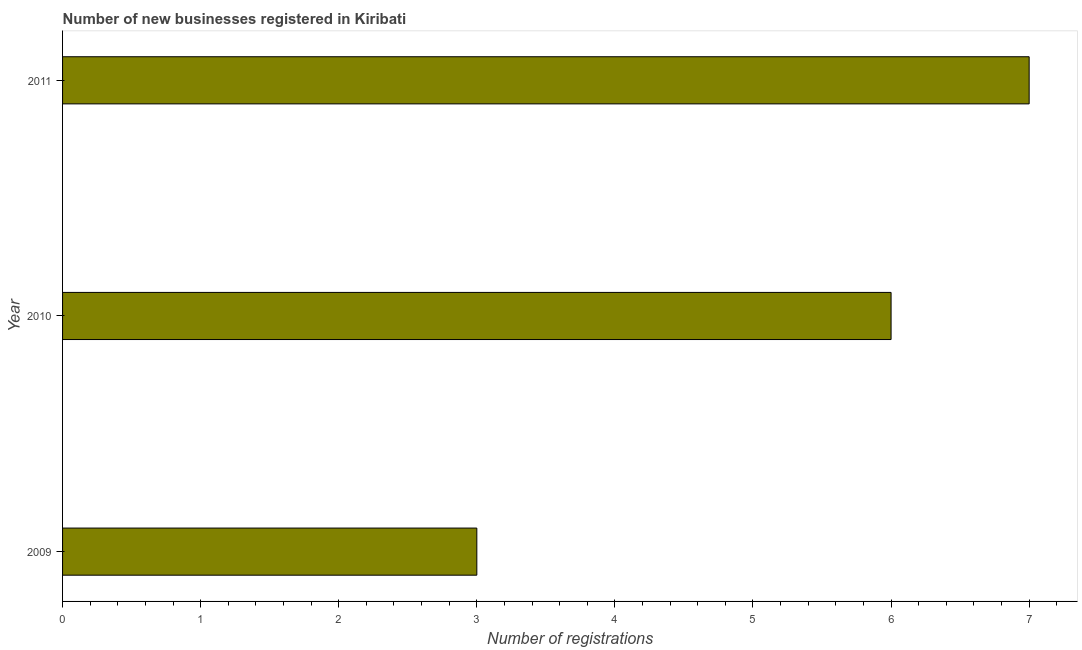Does the graph contain grids?
Provide a short and direct response. No. What is the title of the graph?
Offer a terse response. Number of new businesses registered in Kiribati. What is the label or title of the X-axis?
Offer a terse response. Number of registrations. What is the number of new business registrations in 2011?
Provide a short and direct response. 7. Across all years, what is the maximum number of new business registrations?
Provide a succinct answer. 7. Across all years, what is the minimum number of new business registrations?
Offer a very short reply. 3. What is the sum of the number of new business registrations?
Your response must be concise. 16. What is the difference between the number of new business registrations in 2009 and 2011?
Your answer should be compact. -4. What is the average number of new business registrations per year?
Offer a terse response. 5. Do a majority of the years between 2011 and 2010 (inclusive) have number of new business registrations greater than 2.8 ?
Give a very brief answer. No. What is the ratio of the number of new business registrations in 2009 to that in 2010?
Offer a terse response. 0.5. What is the difference between the highest and the second highest number of new business registrations?
Ensure brevity in your answer.  1. Is the sum of the number of new business registrations in 2009 and 2011 greater than the maximum number of new business registrations across all years?
Make the answer very short. Yes. How many bars are there?
Give a very brief answer. 3. Are the values on the major ticks of X-axis written in scientific E-notation?
Your response must be concise. No. What is the Number of registrations in 2011?
Your answer should be compact. 7. What is the difference between the Number of registrations in 2009 and 2010?
Keep it short and to the point. -3. What is the difference between the Number of registrations in 2009 and 2011?
Your answer should be compact. -4. What is the difference between the Number of registrations in 2010 and 2011?
Provide a short and direct response. -1. What is the ratio of the Number of registrations in 2009 to that in 2011?
Your response must be concise. 0.43. What is the ratio of the Number of registrations in 2010 to that in 2011?
Your answer should be compact. 0.86. 